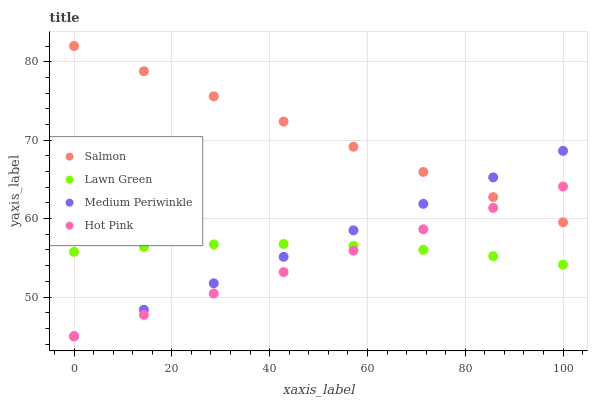Does Hot Pink have the minimum area under the curve?
Answer yes or no. Yes. Does Salmon have the maximum area under the curve?
Answer yes or no. Yes. Does Salmon have the minimum area under the curve?
Answer yes or no. No. Does Hot Pink have the maximum area under the curve?
Answer yes or no. No. Is Medium Periwinkle the smoothest?
Answer yes or no. Yes. Is Lawn Green the roughest?
Answer yes or no. Yes. Is Hot Pink the smoothest?
Answer yes or no. No. Is Hot Pink the roughest?
Answer yes or no. No. Does Hot Pink have the lowest value?
Answer yes or no. Yes. Does Salmon have the lowest value?
Answer yes or no. No. Does Salmon have the highest value?
Answer yes or no. Yes. Does Hot Pink have the highest value?
Answer yes or no. No. Is Lawn Green less than Salmon?
Answer yes or no. Yes. Is Salmon greater than Lawn Green?
Answer yes or no. Yes. Does Hot Pink intersect Medium Periwinkle?
Answer yes or no. Yes. Is Hot Pink less than Medium Periwinkle?
Answer yes or no. No. Is Hot Pink greater than Medium Periwinkle?
Answer yes or no. No. Does Lawn Green intersect Salmon?
Answer yes or no. No. 